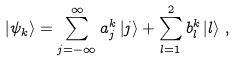<formula> <loc_0><loc_0><loc_500><loc_500>\left | \psi _ { k } \right \rangle = \sum _ { j = - \infty } ^ { \infty } a _ { j } ^ { k } \left | j \right \rangle + \sum _ { l = 1 } ^ { 2 } b _ { l } ^ { k } \left | l \right \rangle \, ,</formula> 